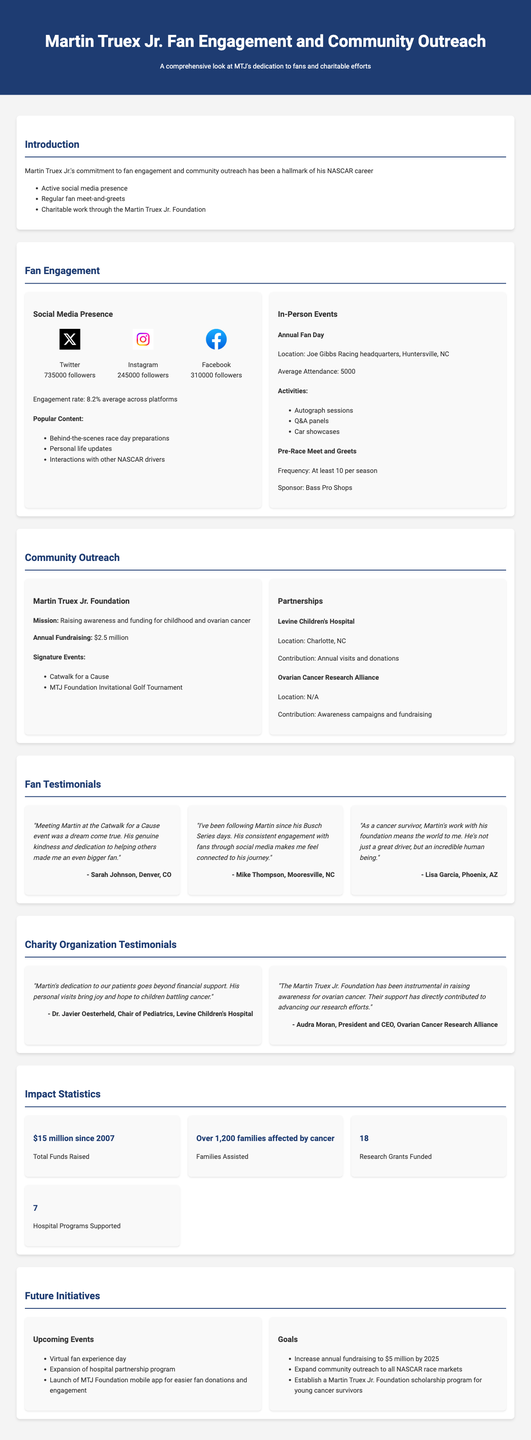What is Martin Truex Jr.'s annual fundraising through his foundation? The document states that the Martin Truex Jr. Foundation raises $2.5 million annually for charitable efforts.
Answer: $2.5 million How many followers does Martin Truex Jr. have on Instagram? The document lists the follower count for Instagram as 245,000.
Answer: 245,000 What is the mission of the Martin Truex Jr. Foundation? The mission, as outlined in the document, is to raise awareness and funding for childhood and ovarian cancer.
Answer: Raising awareness and funding for childhood and ovarian cancer Which organization does Martin Truex Jr. partner with for awareness campaigns? The document mentions the Ovarian Cancer Research Alliance as a partner for awareness campaigns and fundraising.
Answer: Ovarian Cancer Research Alliance What percentage is the average engagement rate across Martin Truex Jr.'s social media platforms? The document states that the average engagement rate is 8.2% across platforms.
Answer: 8.2% What is the average attendance at the Annual Fan Day? The document states that the average attendance for the Annual Fan Day is 5,000 people.
Answer: 5,000 Who is the representative from Levine Children's Hospital that provided a testimonial? The document cites Dr. Javier Oesterheld, Chair of Pediatrics, as the representative giving a testimonial.
Answer: Dr. Javier Oesterheld How many families have been assisted by the Martin Truex Jr. Foundation? According to the document, over 1,200 families affected by cancer have been assisted.
Answer: Over 1,200 families What is one upcoming initiative mentioned in the report? The document lists the launch of the MTJ Foundation mobile app for easier fan donations and engagement as one of the upcoming initiatives.
Answer: Launch of MTJ Foundation mobile app 